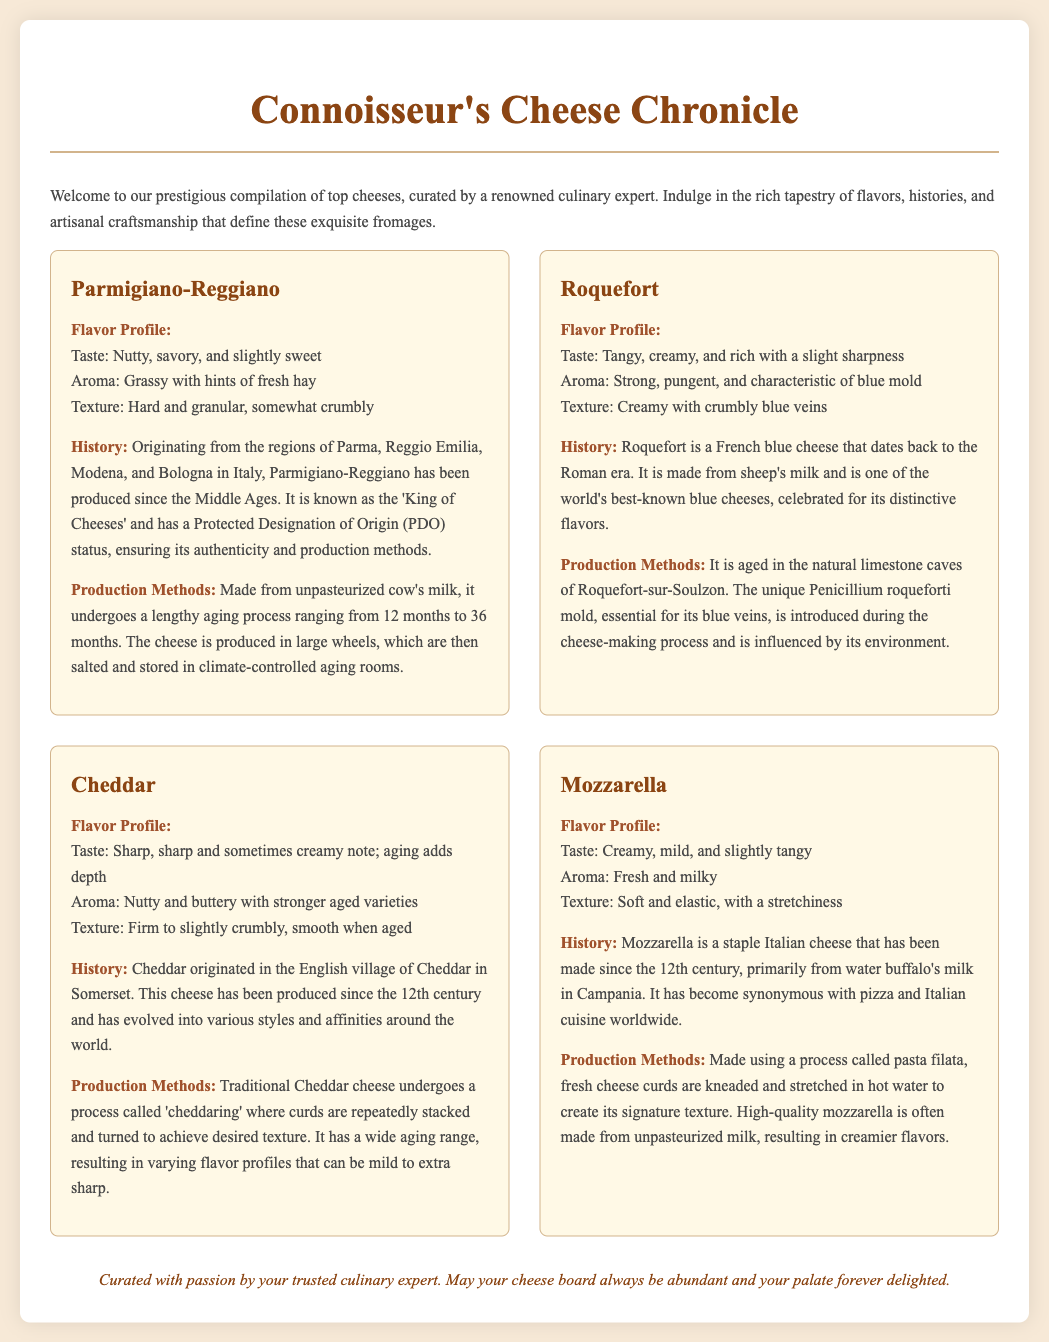what cheese is known as the 'King of Cheeses'? The term 'King of Cheeses' specifically refers to Parmigiano-Reggiano in the document.
Answer: Parmigiano-Reggiano what is the primary milk source used for Roquefort? Roquefort is made from sheep's milk, as stated in its production details.
Answer: sheep's milk how long can Parmigiano-Reggiano be aged? The aging process for Parmigiano-Reggiano ranges from 12 months to 36 months, providing specific information about its aging.
Answer: 12 to 36 months what flavor profile is associated with Cheddar? The flavor profile indicates that Cheddar has a sharp taste and sometimes a creamy note.
Answer: sharp and creamy which production process is used for Mozzarella? The text explains that Mozzarella is made using a method called pasta filata, detailing its production technique.
Answer: pasta filata who curated the cheese document? The footer of the document attributes the compilation to a trusted culinary expert, indicating who is responsible for the content.
Answer: trusted culinary expert where is Roquefort aged? Roquefort is aged in the natural limestone caves of Roquefort-sur-Soulzon, specifying its unique aging location.
Answer: Roquefort-sur-Soulzon what is a distinctive feature of the aroma of Roquefort? The aroma of Roquefort is described as strong and pungent, highlighting its notable scent.
Answer: strong, pungent what texture is described for Mozzarella? The texture of Mozzarella is characterized as soft and elastic, providing a specific detail about its physical properties.
Answer: soft and elastic 